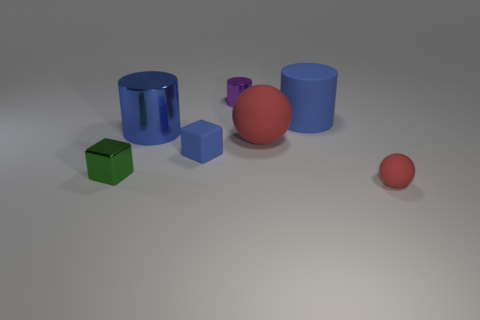Is the shape of the big blue thing that is to the left of the large red thing the same as the green thing? Upon examining the image, the big blue object to the left of the large red sphere is a cylinder, whereas the green object is a cube. Therefore, the shapes are not the same; one is a three-dimensional rectangle with square faces, while the other is a circular prism with two circular faces and a curved surface. 